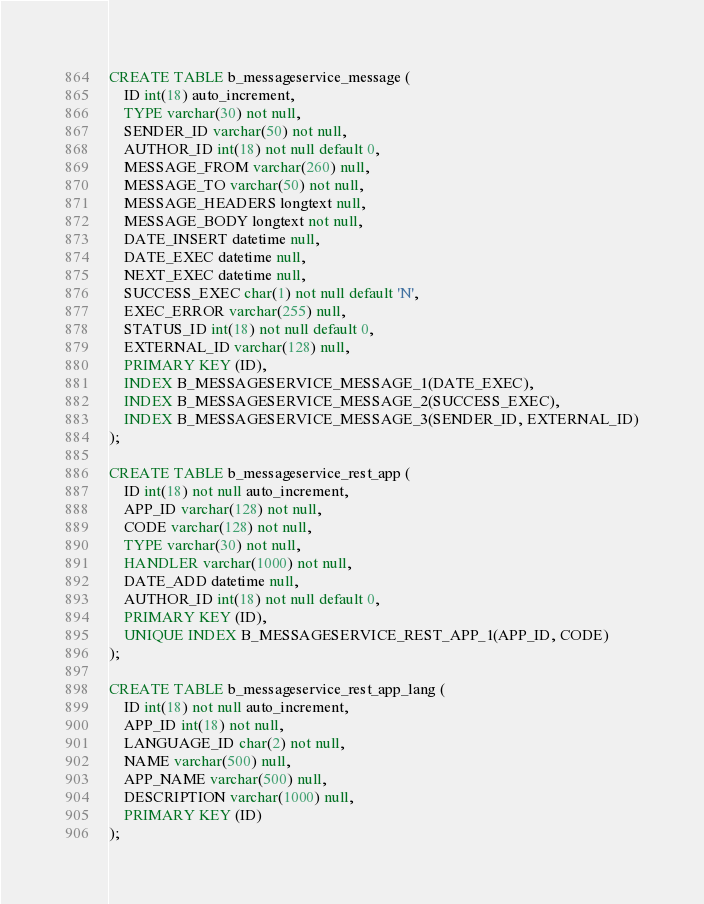Convert code to text. <code><loc_0><loc_0><loc_500><loc_500><_SQL_>CREATE TABLE b_messageservice_message (
	ID int(18) auto_increment,
	TYPE varchar(30) not null,
	SENDER_ID varchar(50) not null,
	AUTHOR_ID int(18) not null default 0,
	MESSAGE_FROM varchar(260) null,
	MESSAGE_TO varchar(50) not null,
	MESSAGE_HEADERS longtext null,
	MESSAGE_BODY longtext not null,
	DATE_INSERT datetime null,
	DATE_EXEC datetime null,
	NEXT_EXEC datetime null,
	SUCCESS_EXEC char(1) not null default 'N',
	EXEC_ERROR varchar(255) null,
	STATUS_ID int(18) not null default 0,
	EXTERNAL_ID varchar(128) null,
	PRIMARY KEY (ID),
	INDEX B_MESSAGESERVICE_MESSAGE_1(DATE_EXEC),
	INDEX B_MESSAGESERVICE_MESSAGE_2(SUCCESS_EXEC),
	INDEX B_MESSAGESERVICE_MESSAGE_3(SENDER_ID, EXTERNAL_ID)
);

CREATE TABLE b_messageservice_rest_app (
	ID int(18) not null auto_increment,
	APP_ID varchar(128) not null,
	CODE varchar(128) not null,
	TYPE varchar(30) not null,
	HANDLER varchar(1000) not null,
	DATE_ADD datetime null,
	AUTHOR_ID int(18) not null default 0,
	PRIMARY KEY (ID),
	UNIQUE INDEX B_MESSAGESERVICE_REST_APP_1(APP_ID, CODE)
);

CREATE TABLE b_messageservice_rest_app_lang (
	ID int(18) not null auto_increment,
	APP_ID int(18) not null,
	LANGUAGE_ID char(2) not null,
	NAME varchar(500) null,
	APP_NAME varchar(500) null,
	DESCRIPTION varchar(1000) null,
	PRIMARY KEY (ID)
);</code> 